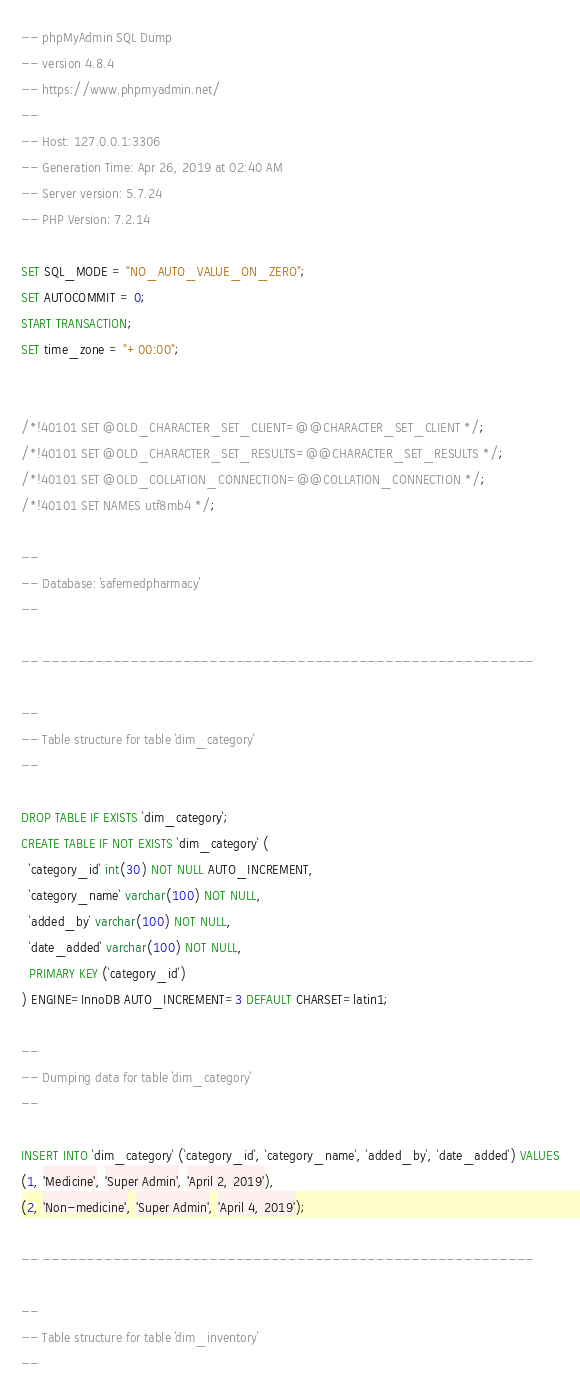Convert code to text. <code><loc_0><loc_0><loc_500><loc_500><_SQL_>-- phpMyAdmin SQL Dump
-- version 4.8.4
-- https://www.phpmyadmin.net/
--
-- Host: 127.0.0.1:3306
-- Generation Time: Apr 26, 2019 at 02:40 AM
-- Server version: 5.7.24
-- PHP Version: 7.2.14

SET SQL_MODE = "NO_AUTO_VALUE_ON_ZERO";
SET AUTOCOMMIT = 0;
START TRANSACTION;
SET time_zone = "+00:00";


/*!40101 SET @OLD_CHARACTER_SET_CLIENT=@@CHARACTER_SET_CLIENT */;
/*!40101 SET @OLD_CHARACTER_SET_RESULTS=@@CHARACTER_SET_RESULTS */;
/*!40101 SET @OLD_COLLATION_CONNECTION=@@COLLATION_CONNECTION */;
/*!40101 SET NAMES utf8mb4 */;

--
-- Database: `safemedpharmacy`
--

-- --------------------------------------------------------

--
-- Table structure for table `dim_category`
--

DROP TABLE IF EXISTS `dim_category`;
CREATE TABLE IF NOT EXISTS `dim_category` (
  `category_id` int(30) NOT NULL AUTO_INCREMENT,
  `category_name` varchar(100) NOT NULL,
  `added_by` varchar(100) NOT NULL,
  `date_added` varchar(100) NOT NULL,
  PRIMARY KEY (`category_id`)
) ENGINE=InnoDB AUTO_INCREMENT=3 DEFAULT CHARSET=latin1;

--
-- Dumping data for table `dim_category`
--

INSERT INTO `dim_category` (`category_id`, `category_name`, `added_by`, `date_added`) VALUES
(1, 'Medicine', 'Super Admin', 'April 2, 2019'),
(2, 'Non-medicine', 'Super Admin', 'April 4, 2019');

-- --------------------------------------------------------

--
-- Table structure for table `dim_inventory`
--
</code> 